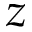<formula> <loc_0><loc_0><loc_500><loc_500>z</formula> 